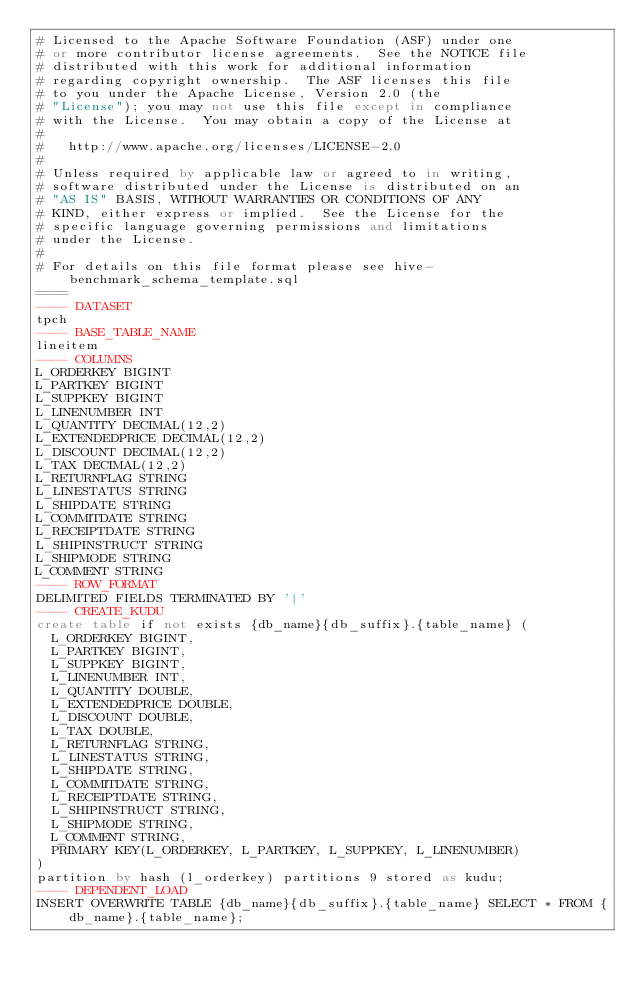<code> <loc_0><loc_0><loc_500><loc_500><_SQL_># Licensed to the Apache Software Foundation (ASF) under one
# or more contributor license agreements.  See the NOTICE file
# distributed with this work for additional information
# regarding copyright ownership.  The ASF licenses this file
# to you under the Apache License, Version 2.0 (the
# "License"); you may not use this file except in compliance
# with the License.  You may obtain a copy of the License at
#
#   http://www.apache.org/licenses/LICENSE-2.0
#
# Unless required by applicable law or agreed to in writing,
# software distributed under the License is distributed on an
# "AS IS" BASIS, WITHOUT WARRANTIES OR CONDITIONS OF ANY
# KIND, either express or implied.  See the License for the
# specific language governing permissions and limitations
# under the License.
#
# For details on this file format please see hive-benchmark_schema_template.sql
====
---- DATASET
tpch
---- BASE_TABLE_NAME
lineitem
---- COLUMNS
L_ORDERKEY BIGINT
L_PARTKEY BIGINT
L_SUPPKEY BIGINT
L_LINENUMBER INT
L_QUANTITY DECIMAL(12,2)
L_EXTENDEDPRICE DECIMAL(12,2)
L_DISCOUNT DECIMAL(12,2)
L_TAX DECIMAL(12,2)
L_RETURNFLAG STRING
L_LINESTATUS STRING
L_SHIPDATE STRING
L_COMMITDATE STRING
L_RECEIPTDATE STRING
L_SHIPINSTRUCT STRING
L_SHIPMODE STRING
L_COMMENT STRING
---- ROW_FORMAT
DELIMITED FIELDS TERMINATED BY '|'
---- CREATE_KUDU
create table if not exists {db_name}{db_suffix}.{table_name} (
  L_ORDERKEY BIGINT,
  L_PARTKEY BIGINT,
  L_SUPPKEY BIGINT,
  L_LINENUMBER INT,
  L_QUANTITY DOUBLE,
  L_EXTENDEDPRICE DOUBLE,
  L_DISCOUNT DOUBLE,
  L_TAX DOUBLE,
  L_RETURNFLAG STRING,
  L_LINESTATUS STRING,
  L_SHIPDATE STRING,
  L_COMMITDATE STRING,
  L_RECEIPTDATE STRING,
  L_SHIPINSTRUCT STRING,
  L_SHIPMODE STRING,
  L_COMMENT STRING,
  PRIMARY KEY(L_ORDERKEY, L_PARTKEY, L_SUPPKEY, L_LINENUMBER)
)
partition by hash (l_orderkey) partitions 9 stored as kudu;
---- DEPENDENT_LOAD
INSERT OVERWRITE TABLE {db_name}{db_suffix}.{table_name} SELECT * FROM {db_name}.{table_name};</code> 